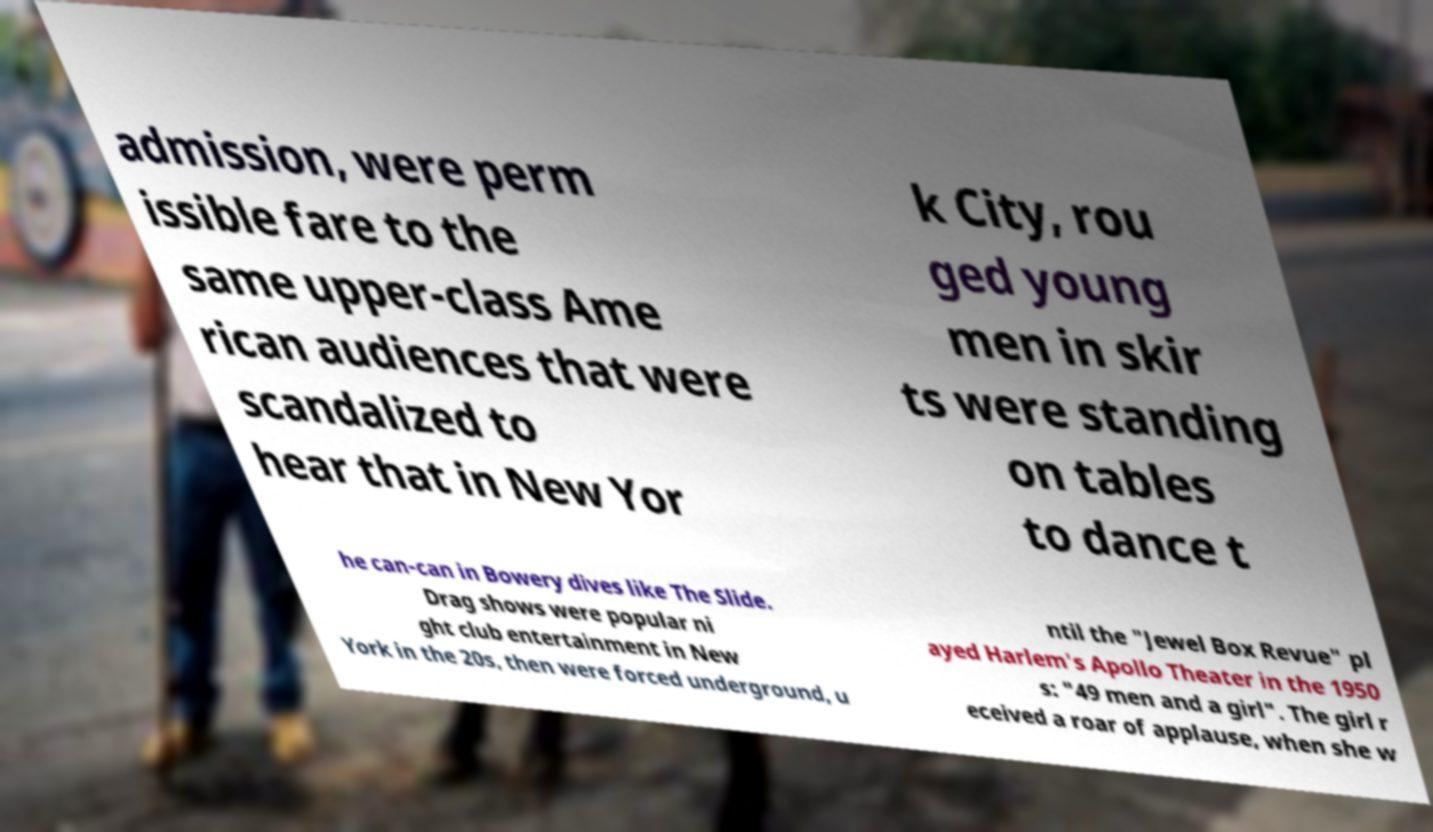Can you read and provide the text displayed in the image?This photo seems to have some interesting text. Can you extract and type it out for me? admission, were perm issible fare to the same upper-class Ame rican audiences that were scandalized to hear that in New Yor k City, rou ged young men in skir ts were standing on tables to dance t he can-can in Bowery dives like The Slide. Drag shows were popular ni ght club entertainment in New York in the 20s, then were forced underground, u ntil the "Jewel Box Revue" pl ayed Harlem's Apollo Theater in the 1950 s: "49 men and a girl". The girl r eceived a roar of applause, when she w 